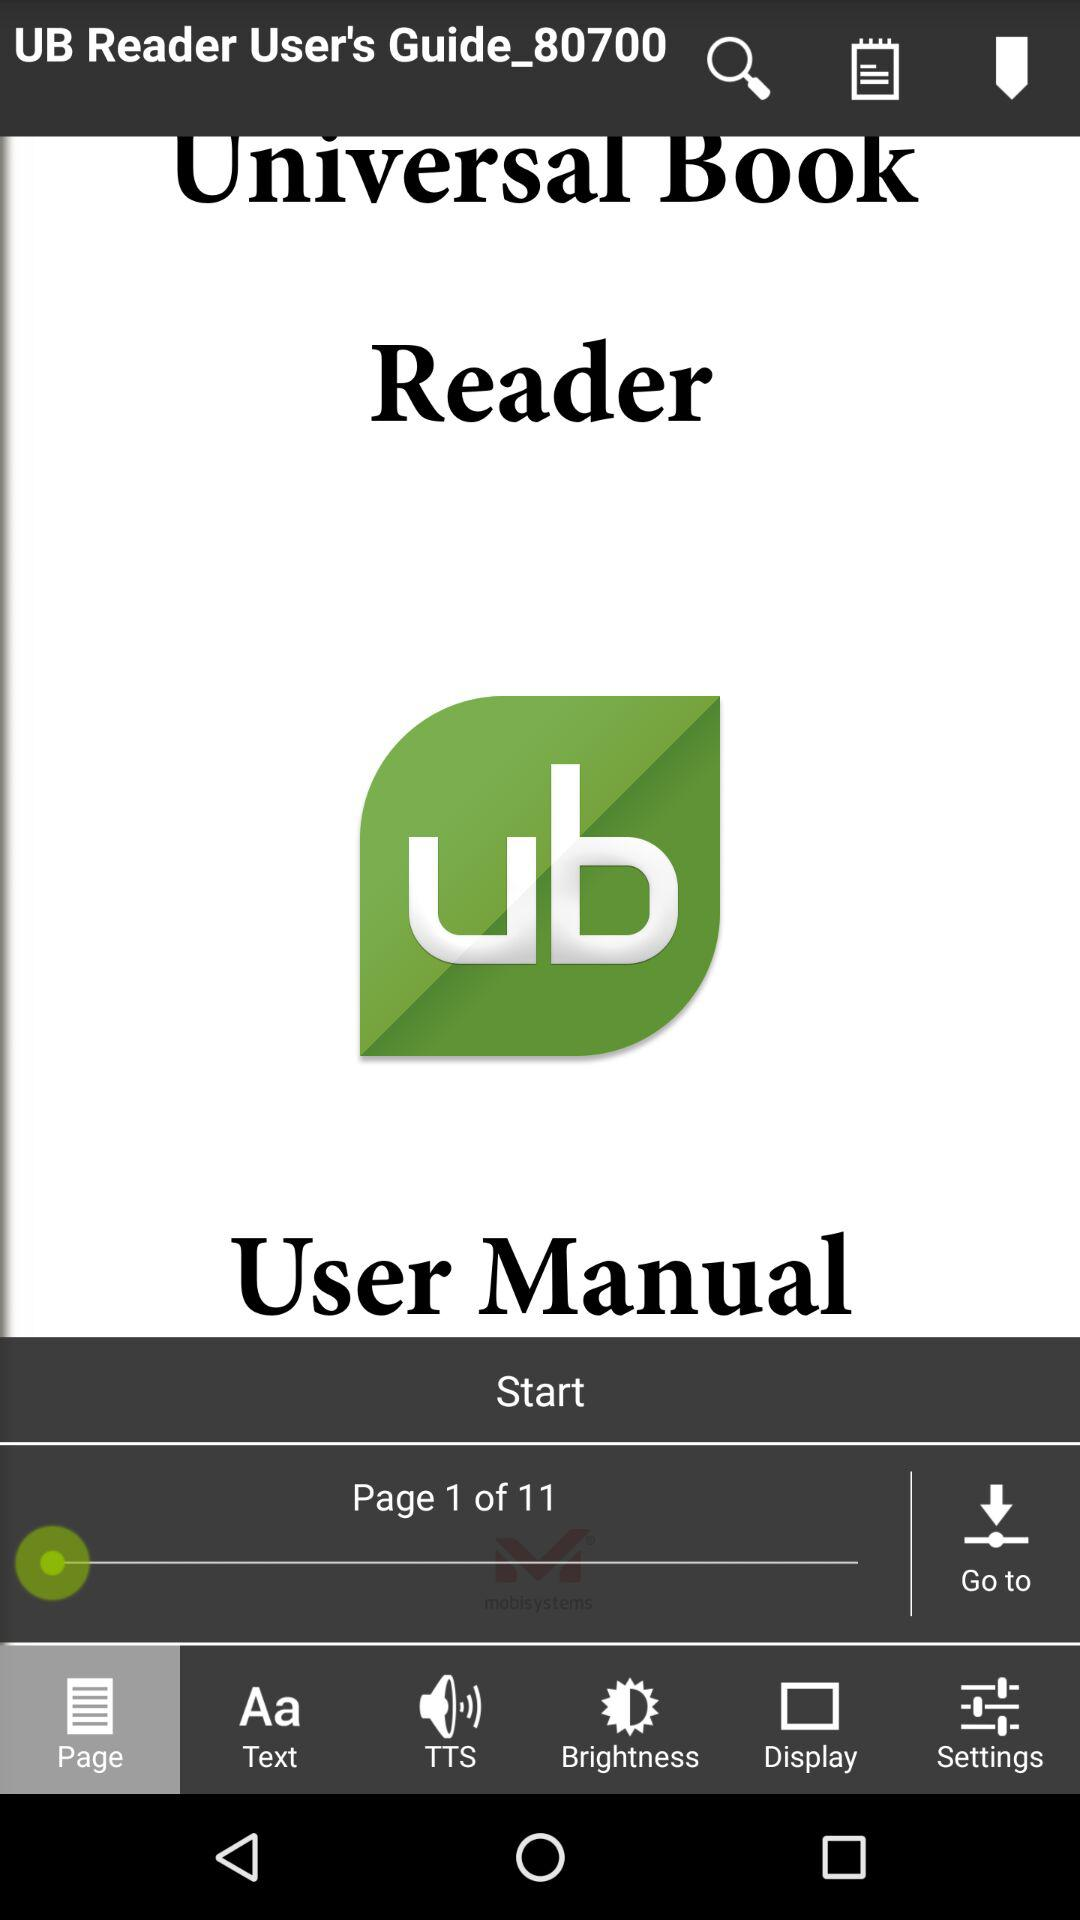How many pages are in the document?
Answer the question using a single word or phrase. 11 